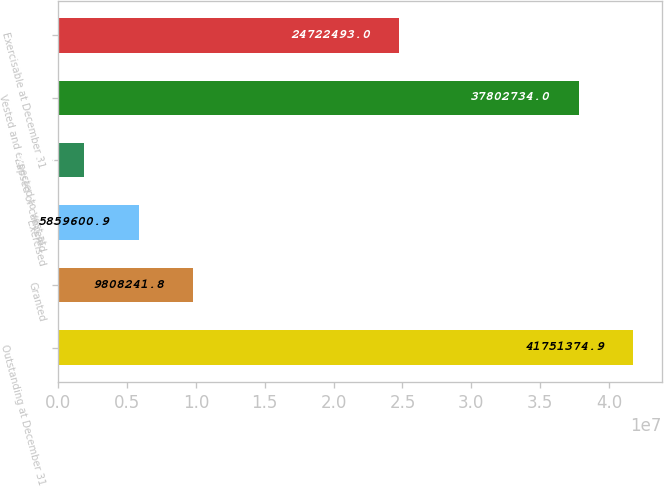<chart> <loc_0><loc_0><loc_500><loc_500><bar_chart><fcel>Outstanding at December 31<fcel>Granted<fcel>Exercised<fcel>Lapsed or canceled<fcel>Vested and expected to vest at<fcel>Exercisable at December 31<nl><fcel>4.17514e+07<fcel>9.80824e+06<fcel>5.8596e+06<fcel>1.91096e+06<fcel>3.78027e+07<fcel>2.47225e+07<nl></chart> 